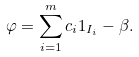<formula> <loc_0><loc_0><loc_500><loc_500>\varphi = \sum _ { i = 1 } ^ { m } c _ { i } 1 _ { I _ { i } } - \beta .</formula> 